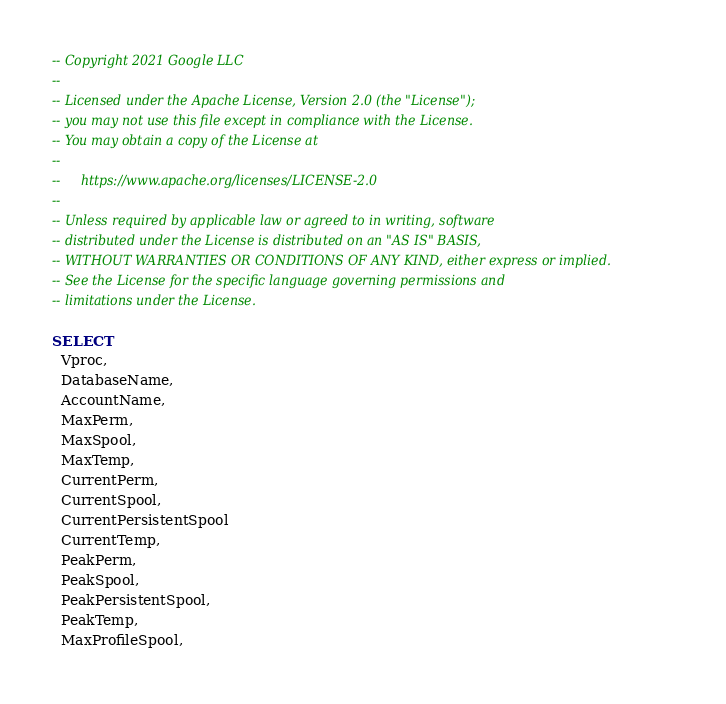Convert code to text. <code><loc_0><loc_0><loc_500><loc_500><_SQL_>-- Copyright 2021 Google LLC
--
-- Licensed under the Apache License, Version 2.0 (the "License");
-- you may not use this file except in compliance with the License.
-- You may obtain a copy of the License at
--
--     https://www.apache.org/licenses/LICENSE-2.0
--
-- Unless required by applicable law or agreed to in writing, software
-- distributed under the License is distributed on an "AS IS" BASIS,
-- WITHOUT WARRANTIES OR CONDITIONS OF ANY KIND, either express or implied.
-- See the License for the specific language governing permissions and
-- limitations under the License.

SELECT
  Vproc,
  DatabaseName,
  AccountName,
  MaxPerm,
  MaxSpool,
  MaxTemp,
  CurrentPerm,
  CurrentSpool,
  CurrentPersistentSpool
  CurrentTemp,
  PeakPerm,
  PeakSpool,
  PeakPersistentSpool,
  PeakTemp,
  MaxProfileSpool,</code> 